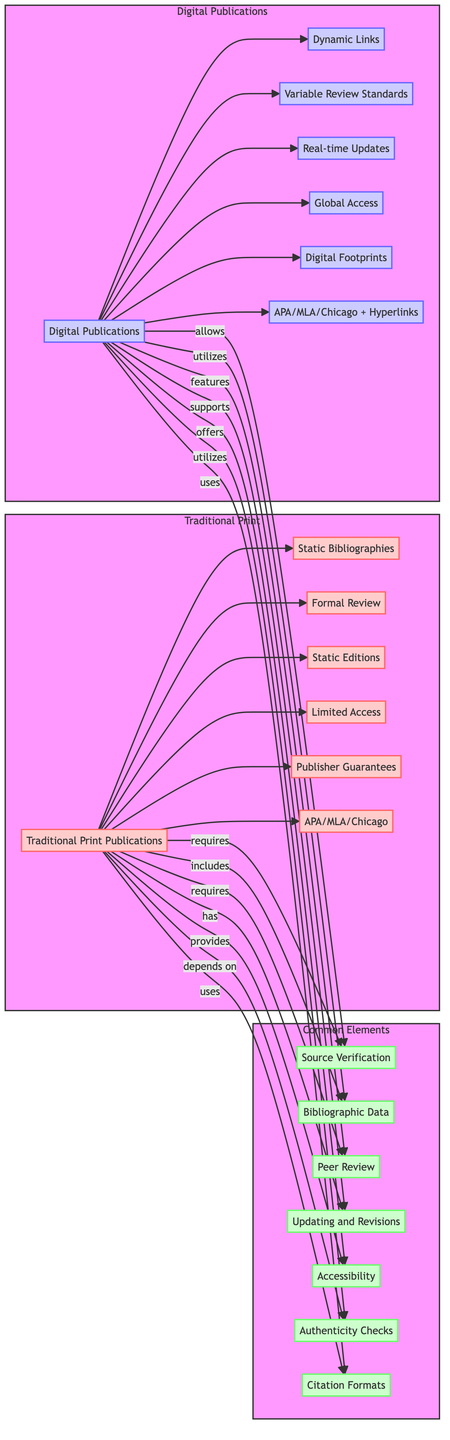What are the two main categories of publication in the diagram? The diagram shows two main categories: Traditional Print Publications and Digital Publications. These categories are represented as distinct subgraphs.
Answer: Traditional Print, Digital Publications Which element requires source verification in both types of publications? Both Traditional Print Publications and Digital Publications require Source Verification, as indicated by the directed arrows towards the common element C1 from both A and B.
Answer: Source Verification How many elements are listed under Traditional Print Publications? The Traditional Print Publications subgraph lists six elements: A1, A2, A3, A4, A5, and A6. Counting these elements gives a total of six.
Answer: 6 What format is used by both Traditional Print and Digital Publications for citations? Both publication types utilize citation formats identified as APA, MLA, and Chicago, which is reflected by the usage of element C7 in both subnetworks.
Answer: APA, MLA, Chicago Which type of publication supports real-time updates? The Digital Publications support real-time updates, as shown by the directed arrow from B to B3. This indicates a feature unique to digital formats in the diagram.
Answer: Digital Publications What is unique about Digital Publications compared to Traditional Print in terms of access? Digital Publications offer Global Access, contrasting with Traditional Print Publications, which have Limited Access. This is evident from the respective elements B4 and A4 in their subgraphs.
Answer: Global Access How many common elements exist in the diagram? The diagram features seven common elements: C1 (Source Verification), C2 (Bibliographic Data), C3 (Peer Review), C4 (Updating and Revisions), C5 (Accessibility), C6 (Authenticity Checks), and C7 (Citation Formats), totaling seven.
Answer: 7 Which common element mentions authenticity checks? The authenticity checks are referred to in the common element labeled C6, which is highlighted in the overlap of the Traditional Print and Digital Publications categories.
Answer: Authenticity Checks What element characterizes Digital Publications regarding citation formats? Digital Publications use citation formats identified as APA, MLA, Chicago along with Hyperlinks, indicated by B6, which distinguishes it from the Traditional Print representation.
Answer: APA, MLA, Chicago + Hyperlinks 